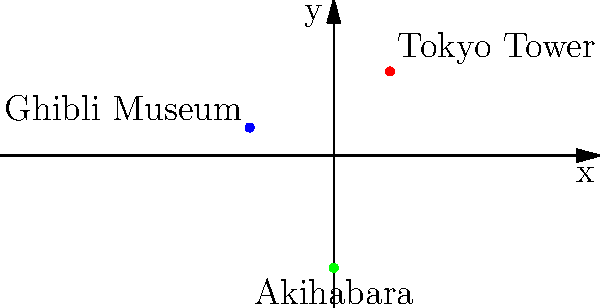In the city grid above, three iconic anime landmarks are plotted: Tokyo Tower, Ghibli Museum, and Akihabara. If an anime enthusiast starts at Tokyo Tower and wants to visit all three locations in the order they appear in the list, what is the total distance traveled in coordinate units? To solve this problem, we need to calculate the distances between the landmarks in the order given:

1. Start at Tokyo Tower (2, 3)
2. Move to Ghibli Museum (-3, 1)
3. End at Akihabara (0, -4)

Let's calculate each distance using the distance formula:
$d = \sqrt{(x_2 - x_1)^2 + (y_2 - y_1)^2}$

Step 1: Distance from Tokyo Tower to Ghibli Museum
$d_1 = \sqrt{(-3 - 2)^2 + (1 - 3)^2} = \sqrt{(-5)^2 + (-2)^2} = \sqrt{25 + 4} = \sqrt{29}$

Step 2: Distance from Ghibli Museum to Akihabara
$d_2 = \sqrt{(0 - (-3))^2 + (-4 - 1)^2} = \sqrt{3^2 + (-5)^2} = \sqrt{9 + 25} = \sqrt{34}$

Step 3: Calculate the total distance
Total distance = $d_1 + d_2 = \sqrt{29} + \sqrt{34}$

The exact value is $\sqrt{29} + \sqrt{34}$, which is approximately 11.39 coordinate units.
Answer: $\sqrt{29} + \sqrt{34}$ 